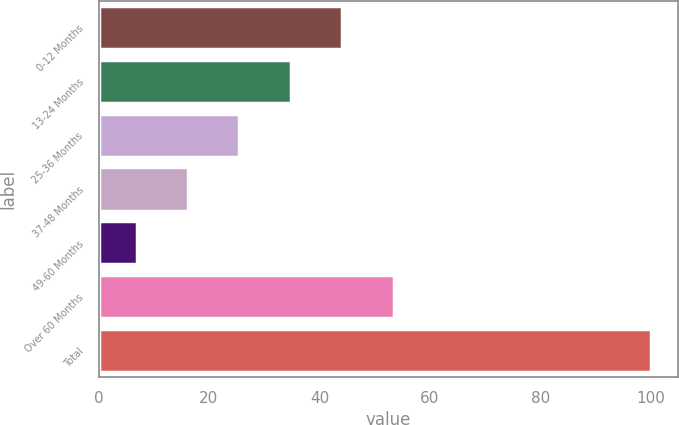Convert chart to OTSL. <chart><loc_0><loc_0><loc_500><loc_500><bar_chart><fcel>0-12 Months<fcel>13-24 Months<fcel>25-36 Months<fcel>37-48 Months<fcel>49-60 Months<fcel>Over 60 Months<fcel>Total<nl><fcel>44.14<fcel>34.83<fcel>25.52<fcel>16.21<fcel>6.9<fcel>53.45<fcel>100<nl></chart> 